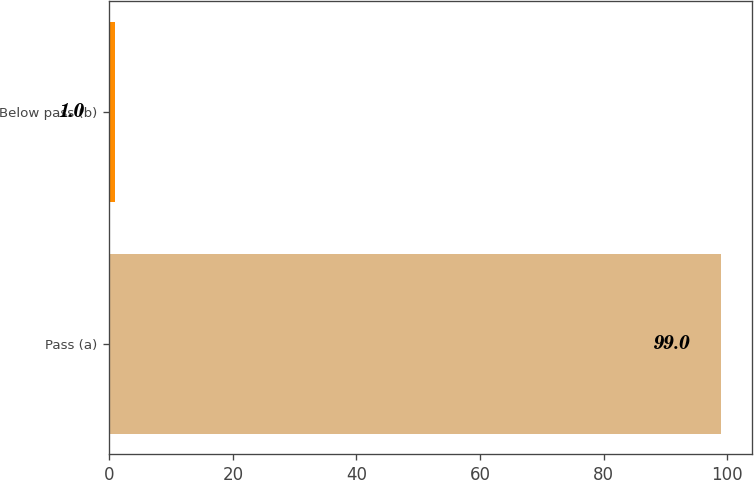<chart> <loc_0><loc_0><loc_500><loc_500><bar_chart><fcel>Pass (a)<fcel>Below pass (b)<nl><fcel>99<fcel>1<nl></chart> 